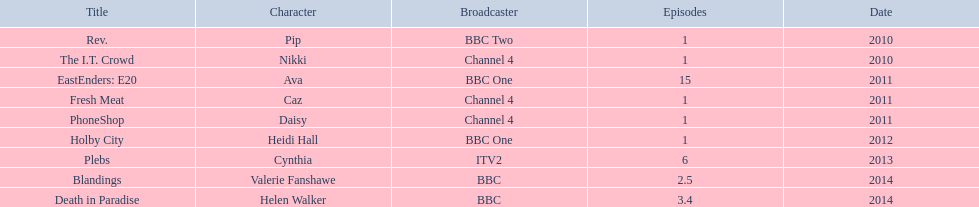What positions did she take on? Pip, Nikki, Ava, Caz, Daisy, Heidi Hall, Cynthia, Valerie Fanshawe, Helen Walker. Could you parse the entire table as a dict? {'header': ['Title', 'Character', 'Broadcaster', 'Episodes', 'Date'], 'rows': [['Rev.', 'Pip', 'BBC Two', '1', '2010'], ['The I.T. Crowd', 'Nikki', 'Channel 4', '1', '2010'], ['EastEnders: E20', 'Ava', 'BBC One', '15', '2011'], ['Fresh Meat', 'Caz', 'Channel 4', '1', '2011'], ['PhoneShop', 'Daisy', 'Channel 4', '1', '2011'], ['Holby City', 'Heidi Hall', 'BBC One', '1', '2012'], ['Plebs', 'Cynthia', 'ITV2', '6', '2013'], ['Blandings', 'Valerie Fanshawe', 'BBC', '2.5', '2014'], ['Death in Paradise', 'Helen Walker', 'BBC', '3.4', '2014']]} On which broadcasting platforms? BBC Two, Channel 4, BBC One, Channel 4, Channel 4, BBC One, ITV2, BBC, BBC. Which positions did she assume for itv2? Cynthia. 